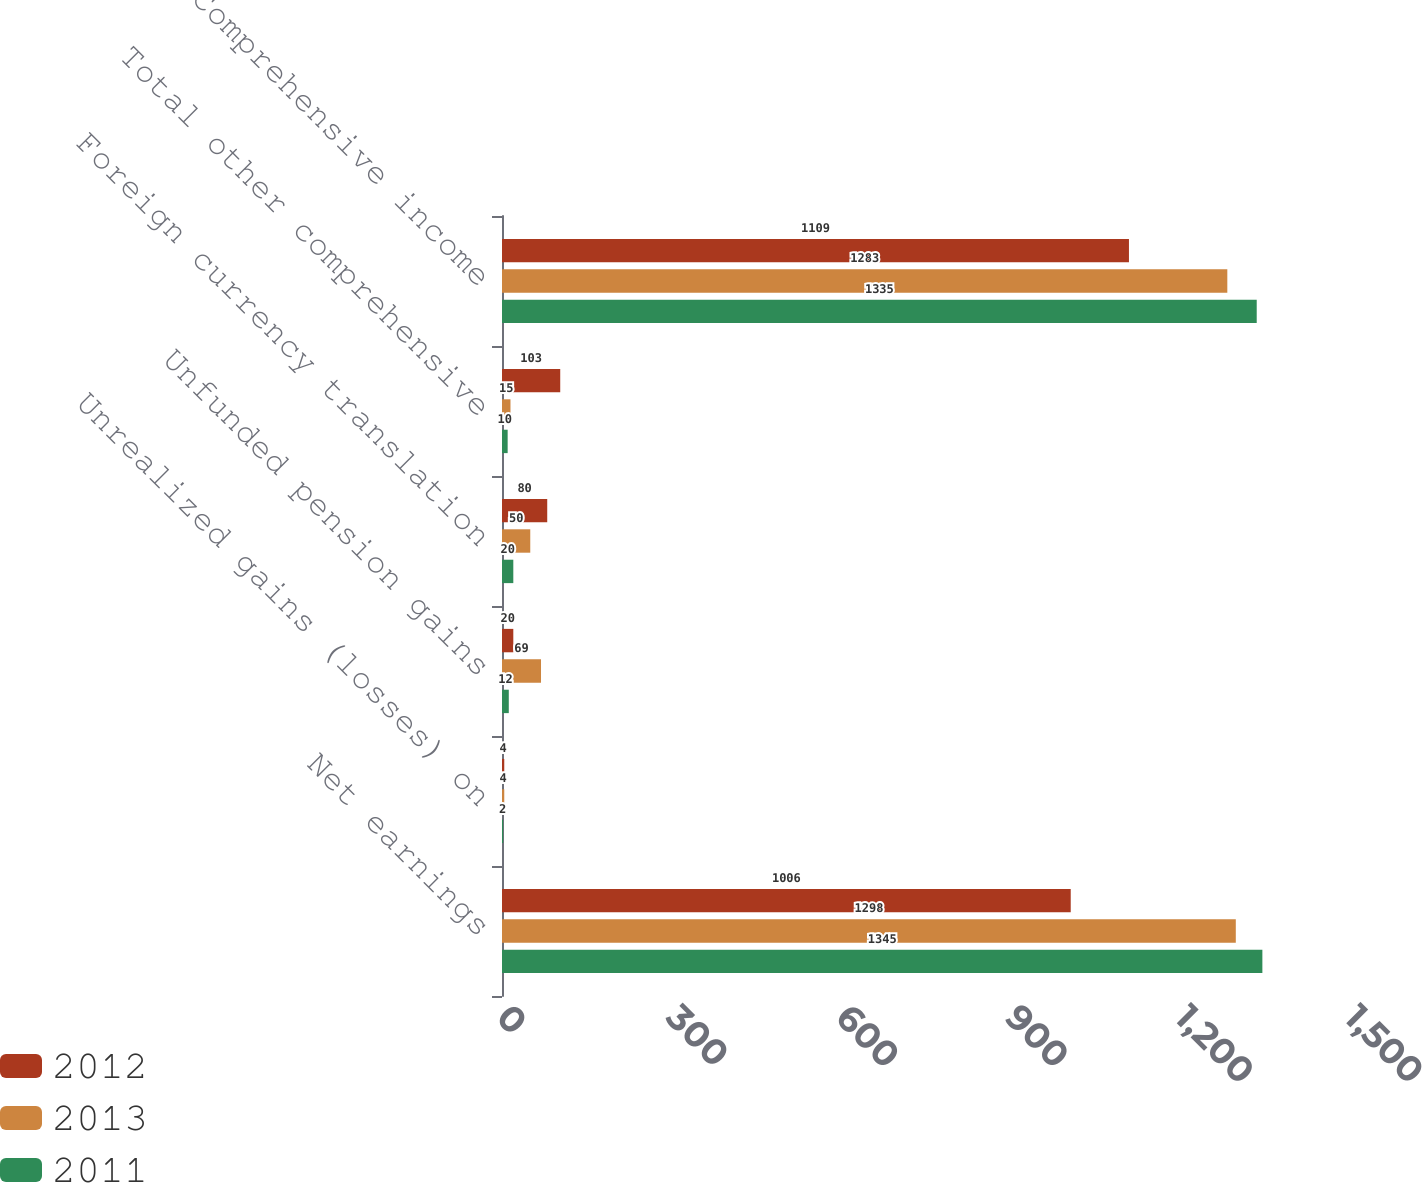<chart> <loc_0><loc_0><loc_500><loc_500><stacked_bar_chart><ecel><fcel>Net earnings<fcel>Unrealized gains (losses) on<fcel>Unfunded pension gains<fcel>Foreign currency translation<fcel>Total other comprehensive<fcel>Comprehensive income<nl><fcel>2012<fcel>1006<fcel>4<fcel>20<fcel>80<fcel>103<fcel>1109<nl><fcel>2013<fcel>1298<fcel>4<fcel>69<fcel>50<fcel>15<fcel>1283<nl><fcel>2011<fcel>1345<fcel>2<fcel>12<fcel>20<fcel>10<fcel>1335<nl></chart> 